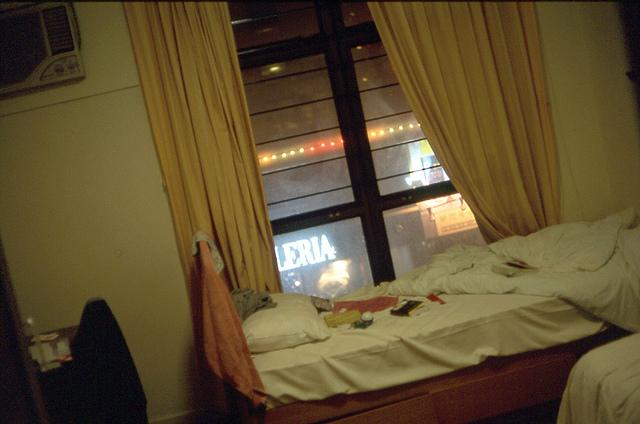The last four letters seen in the background are all found in what word?

Choices:
A) pizzeria
B) loquacious
C) quash
D) sublime pizzeria 